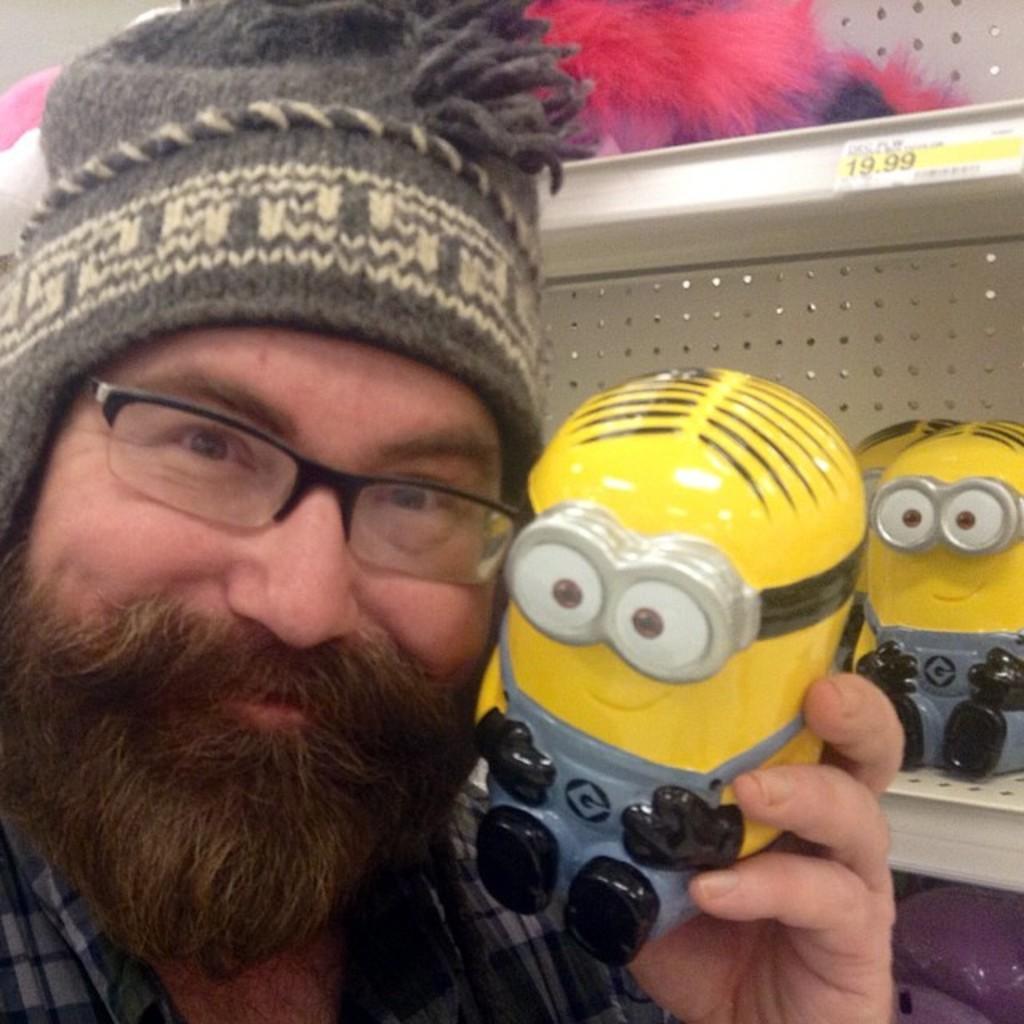How would you summarize this image in a sentence or two? In this image on the left there is a man, he wears a shirt, cap, he is smiling, he is holding a toy. In the background there are shelves on them there are toys and posters. 